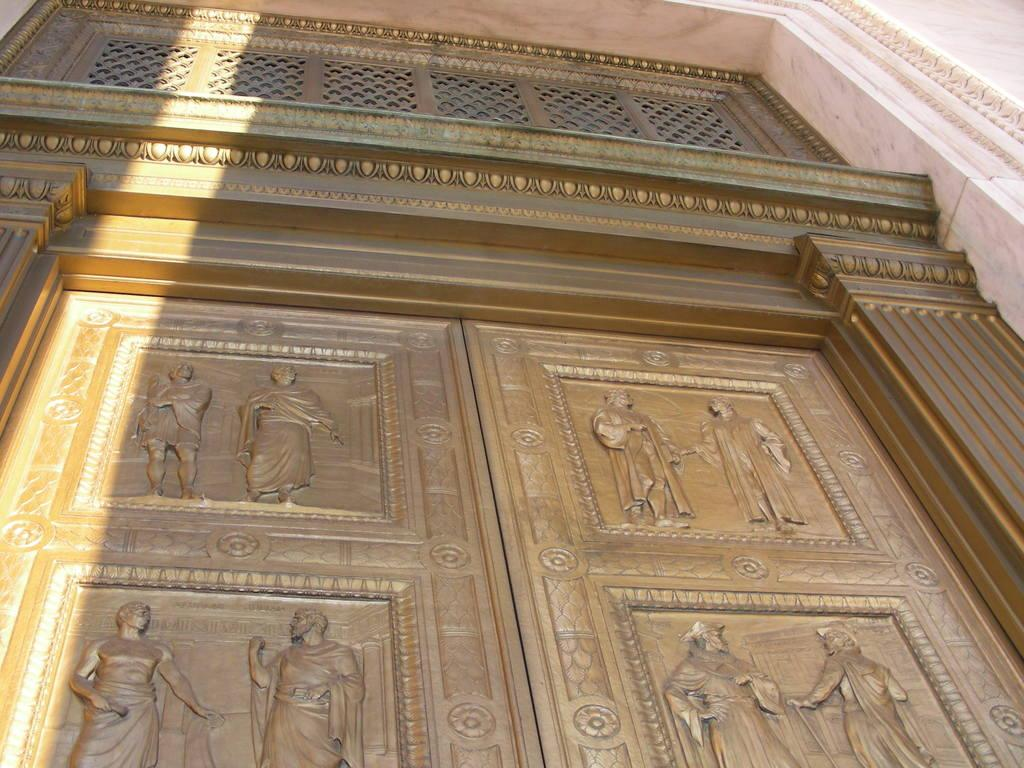What is depicted on the doors in the image? There are sculptures of people on the doors. What can be seen behind the doors in the image? There is a wall visible in the image. Can you see a volleyball game being played on the wall in the image? There is no volleyball game or any reference to a volleyball in the image; it only features sculptures of people on the doors and a wall. 